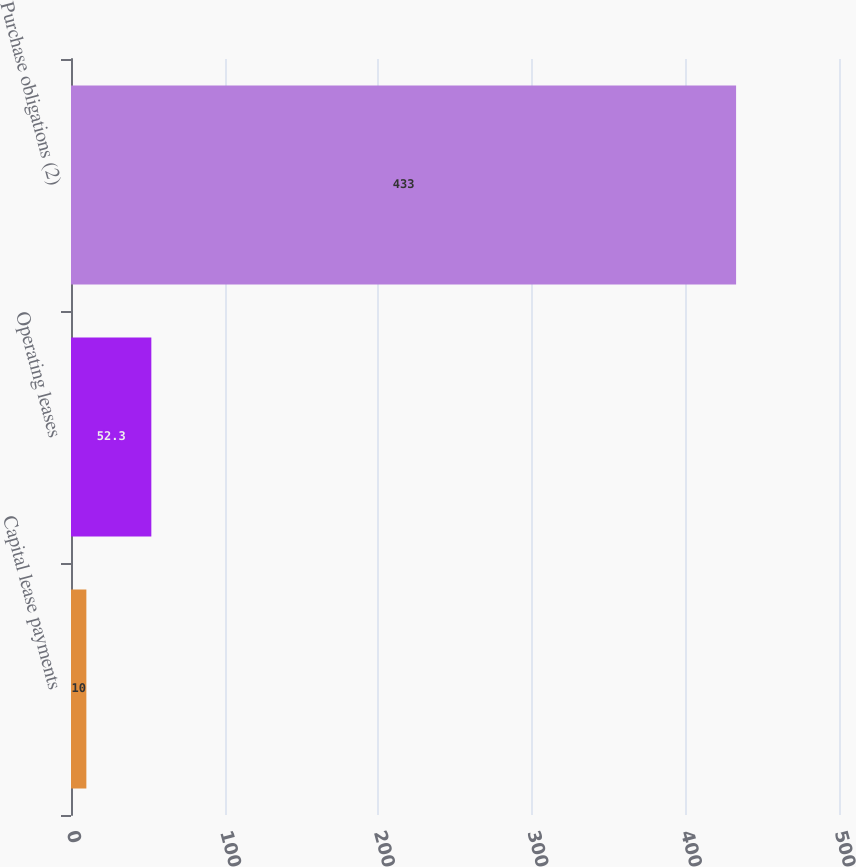Convert chart to OTSL. <chart><loc_0><loc_0><loc_500><loc_500><bar_chart><fcel>Capital lease payments<fcel>Operating leases<fcel>Purchase obligations (2)<nl><fcel>10<fcel>52.3<fcel>433<nl></chart> 